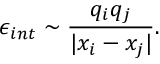<formula> <loc_0><loc_0><loc_500><loc_500>\epsilon _ { i n t } \sim \frac { q _ { i } q _ { j } } { | x _ { i } - x _ { j } | } .</formula> 